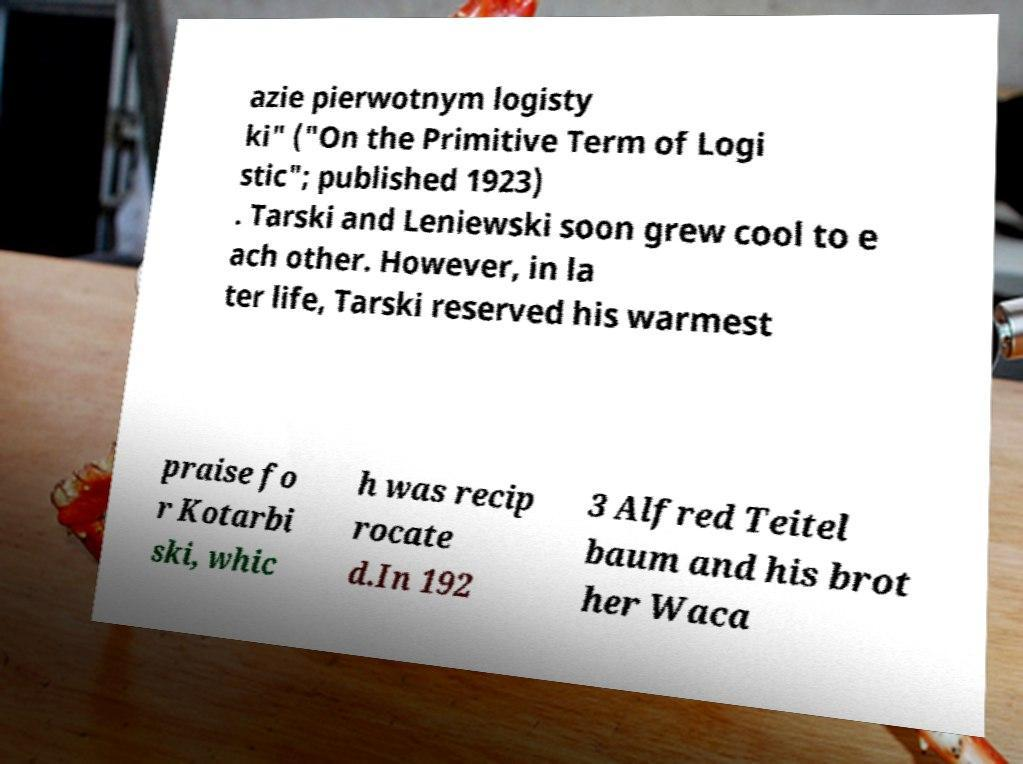Can you accurately transcribe the text from the provided image for me? azie pierwotnym logisty ki" ("On the Primitive Term of Logi stic"; published 1923) . Tarski and Leniewski soon grew cool to e ach other. However, in la ter life, Tarski reserved his warmest praise fo r Kotarbi ski, whic h was recip rocate d.In 192 3 Alfred Teitel baum and his brot her Waca 